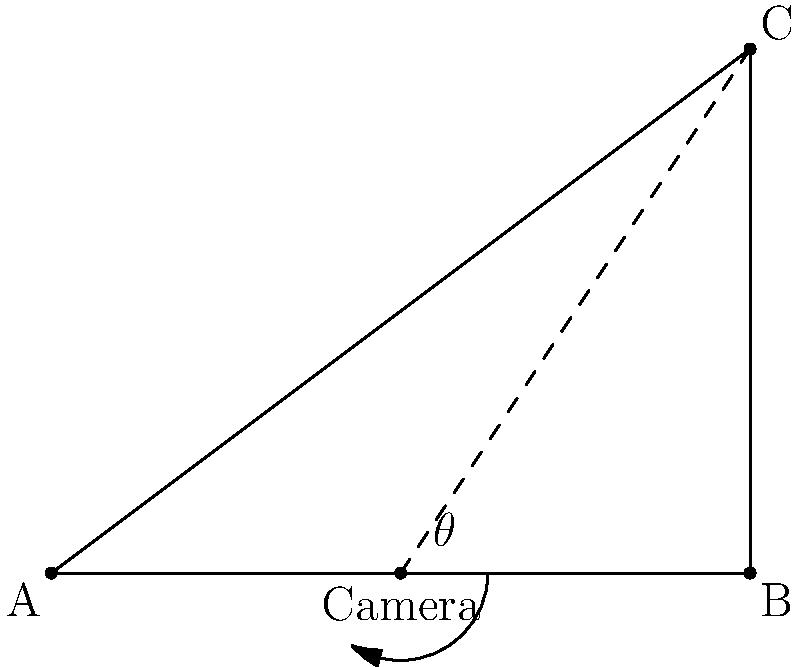A security camera is positioned at point (4,0) in a rectangular room with dimensions 8x6 units. The camera needs to cover the entire width of the room from corner A (0,0) to corner C (8,6). Calculate the viewing angle $\theta$ of the camera required to capture this area. To solve this problem, we'll follow these steps:

1) First, we need to calculate the angles between the camera and points A and C.

2) For point A:
   $\tan \alpha = \frac{0-0}{0-4} = 0$
   $\alpha = \arctan(0) = 0°$

3) For point C:
   $\tan \beta = \frac{6-0}{8-4} = \frac{3}{2} = 1.5$
   $\beta = \arctan(1.5) \approx 56.31°$

4) The viewing angle $\theta$ is the difference between these two angles:

   $\theta = \beta - \alpha = 56.31° - 0° = 56.31°$

5) We can also use the atan2 function for more precise calculation:

   $\theta = \arctan2(6, 4) - \arctan2(0, -4) \approx 56.31°$

Therefore, the required viewing angle of the camera is approximately 56.31°.
Answer: $56.31°$ 